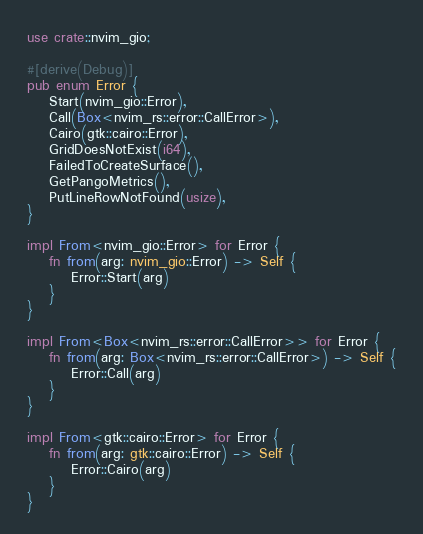Convert code to text. <code><loc_0><loc_0><loc_500><loc_500><_Rust_>use crate::nvim_gio;

#[derive(Debug)]
pub enum Error {
    Start(nvim_gio::Error),
    Call(Box<nvim_rs::error::CallError>),
    Cairo(gtk::cairo::Error),
    GridDoesNotExist(i64),
    FailedToCreateSurface(),
    GetPangoMetrics(),
    PutLineRowNotFound(usize),
}

impl From<nvim_gio::Error> for Error {
    fn from(arg: nvim_gio::Error) -> Self {
        Error::Start(arg)
    }
}

impl From<Box<nvim_rs::error::CallError>> for Error {
    fn from(arg: Box<nvim_rs::error::CallError>) -> Self {
        Error::Call(arg)
    }
}

impl From<gtk::cairo::Error> for Error {
    fn from(arg: gtk::cairo::Error) -> Self {
        Error::Cairo(arg)
    }
}
</code> 